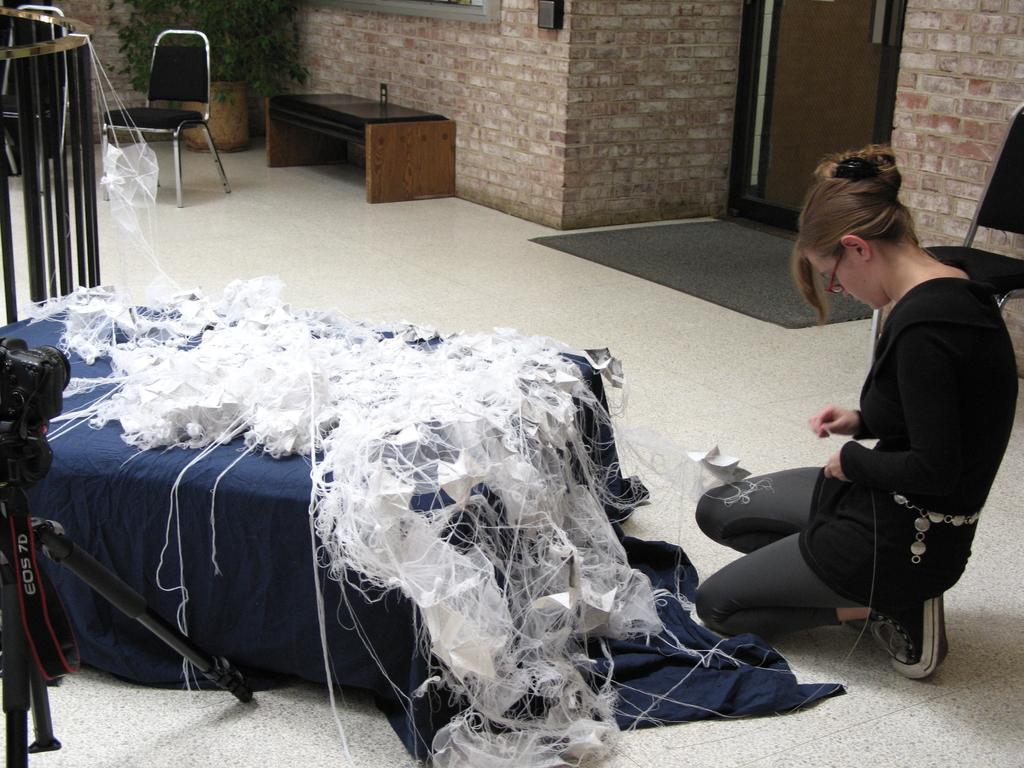Describe this image in one or two sentences. A lady is sitting wearing specs and holding a thread. There is a table. On the table there are papers and many threads. There is a camera and a tripod stand. In the background there is a brick wall, door, bench, chair and a carpet. 